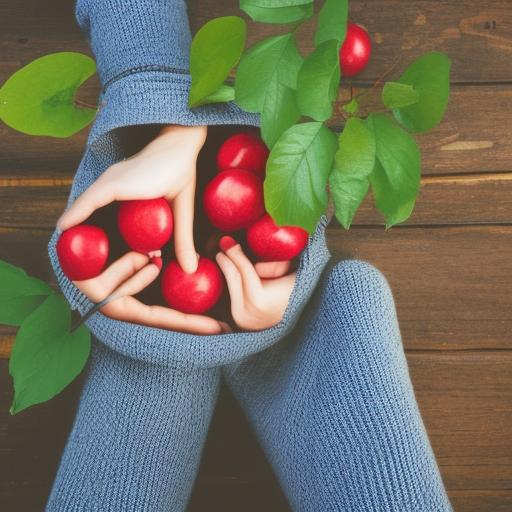What can you tell me about the subject being highlighted in this image? The image draws attention to a pair of hands cradling a collection of red apples. This focus on the hands and apples creates a warm, nurturing theme, potentially emphasizing concepts such as nature's bounty, health, or abundance. 